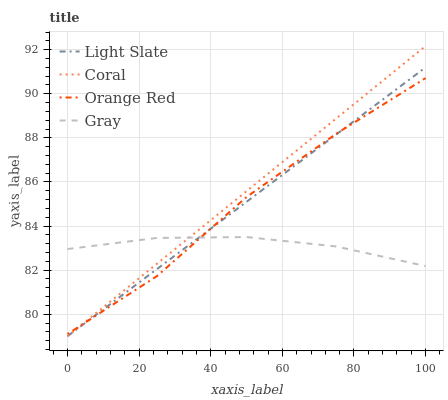Does Gray have the minimum area under the curve?
Answer yes or no. Yes. Does Coral have the maximum area under the curve?
Answer yes or no. Yes. Does Coral have the minimum area under the curve?
Answer yes or no. No. Does Gray have the maximum area under the curve?
Answer yes or no. No. Is Coral the smoothest?
Answer yes or no. Yes. Is Orange Red the roughest?
Answer yes or no. Yes. Is Gray the smoothest?
Answer yes or no. No. Is Gray the roughest?
Answer yes or no. No. Does Light Slate have the lowest value?
Answer yes or no. Yes. Does Gray have the lowest value?
Answer yes or no. No. Does Coral have the highest value?
Answer yes or no. Yes. Does Gray have the highest value?
Answer yes or no. No. Does Gray intersect Orange Red?
Answer yes or no. Yes. Is Gray less than Orange Red?
Answer yes or no. No. Is Gray greater than Orange Red?
Answer yes or no. No. 